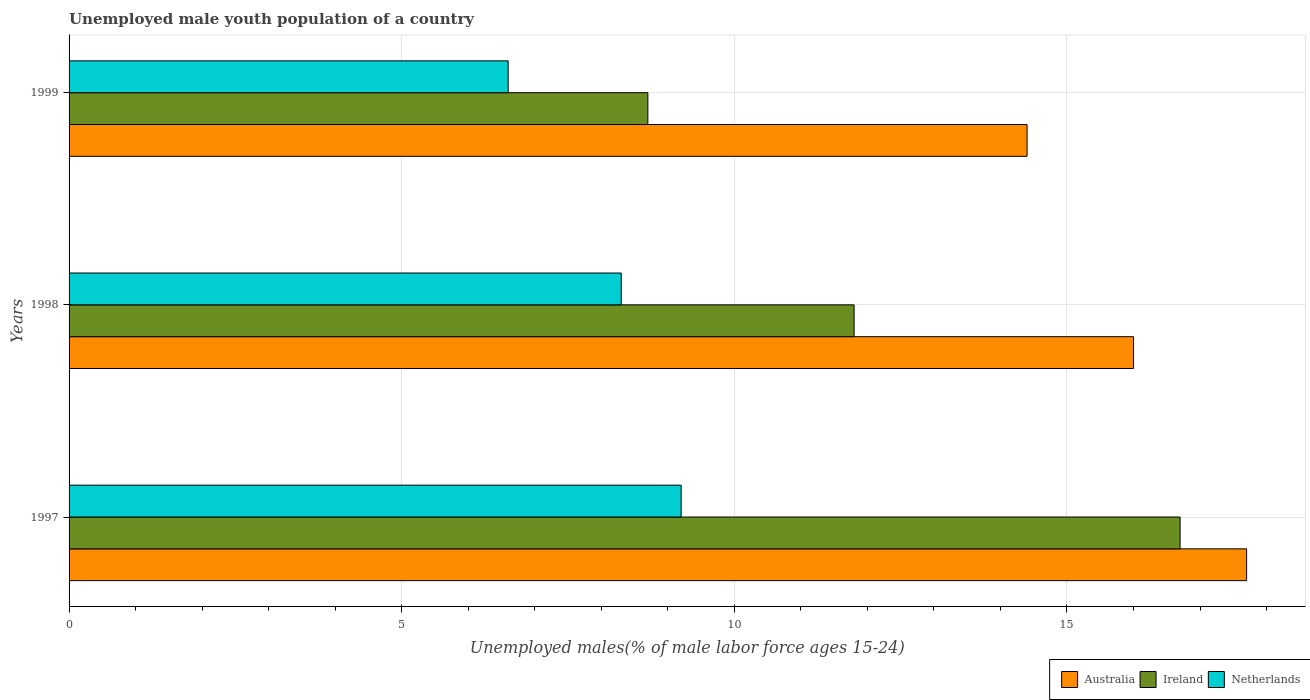How many different coloured bars are there?
Your response must be concise. 3. How many groups of bars are there?
Offer a terse response. 3. Are the number of bars per tick equal to the number of legend labels?
Ensure brevity in your answer.  Yes. How many bars are there on the 3rd tick from the top?
Ensure brevity in your answer.  3. How many bars are there on the 3rd tick from the bottom?
Provide a succinct answer. 3. Across all years, what is the maximum percentage of unemployed male youth population in Ireland?
Your response must be concise. 16.7. Across all years, what is the minimum percentage of unemployed male youth population in Netherlands?
Your answer should be very brief. 6.6. In which year was the percentage of unemployed male youth population in Ireland maximum?
Your answer should be compact. 1997. What is the total percentage of unemployed male youth population in Ireland in the graph?
Your response must be concise. 37.2. What is the difference between the percentage of unemployed male youth population in Ireland in 1997 and that in 1998?
Keep it short and to the point. 4.9. What is the difference between the percentage of unemployed male youth population in Australia in 1998 and the percentage of unemployed male youth population in Netherlands in 1999?
Provide a succinct answer. 9.4. What is the average percentage of unemployed male youth population in Australia per year?
Your response must be concise. 16.03. In the year 1998, what is the difference between the percentage of unemployed male youth population in Australia and percentage of unemployed male youth population in Ireland?
Your answer should be very brief. 4.2. In how many years, is the percentage of unemployed male youth population in Netherlands greater than 12 %?
Ensure brevity in your answer.  0. What is the ratio of the percentage of unemployed male youth population in Australia in 1997 to that in 1999?
Your answer should be very brief. 1.23. Is the difference between the percentage of unemployed male youth population in Australia in 1998 and 1999 greater than the difference between the percentage of unemployed male youth population in Ireland in 1998 and 1999?
Your answer should be compact. No. What is the difference between the highest and the second highest percentage of unemployed male youth population in Ireland?
Your answer should be compact. 4.9. What is the difference between the highest and the lowest percentage of unemployed male youth population in Australia?
Offer a very short reply. 3.3. Is the sum of the percentage of unemployed male youth population in Netherlands in 1997 and 1999 greater than the maximum percentage of unemployed male youth population in Australia across all years?
Your answer should be compact. No. What does the 2nd bar from the top in 1999 represents?
Make the answer very short. Ireland. What does the 2nd bar from the bottom in 1999 represents?
Provide a short and direct response. Ireland. Are the values on the major ticks of X-axis written in scientific E-notation?
Ensure brevity in your answer.  No. Does the graph contain grids?
Your response must be concise. Yes. Where does the legend appear in the graph?
Offer a terse response. Bottom right. How are the legend labels stacked?
Provide a short and direct response. Horizontal. What is the title of the graph?
Provide a short and direct response. Unemployed male youth population of a country. Does "Lebanon" appear as one of the legend labels in the graph?
Ensure brevity in your answer.  No. What is the label or title of the X-axis?
Offer a very short reply. Unemployed males(% of male labor force ages 15-24). What is the label or title of the Y-axis?
Keep it short and to the point. Years. What is the Unemployed males(% of male labor force ages 15-24) of Australia in 1997?
Offer a very short reply. 17.7. What is the Unemployed males(% of male labor force ages 15-24) in Ireland in 1997?
Your answer should be compact. 16.7. What is the Unemployed males(% of male labor force ages 15-24) of Netherlands in 1997?
Keep it short and to the point. 9.2. What is the Unemployed males(% of male labor force ages 15-24) of Australia in 1998?
Provide a succinct answer. 16. What is the Unemployed males(% of male labor force ages 15-24) of Ireland in 1998?
Offer a terse response. 11.8. What is the Unemployed males(% of male labor force ages 15-24) in Netherlands in 1998?
Provide a succinct answer. 8.3. What is the Unemployed males(% of male labor force ages 15-24) in Australia in 1999?
Make the answer very short. 14.4. What is the Unemployed males(% of male labor force ages 15-24) in Ireland in 1999?
Give a very brief answer. 8.7. What is the Unemployed males(% of male labor force ages 15-24) of Netherlands in 1999?
Provide a succinct answer. 6.6. Across all years, what is the maximum Unemployed males(% of male labor force ages 15-24) of Australia?
Give a very brief answer. 17.7. Across all years, what is the maximum Unemployed males(% of male labor force ages 15-24) in Ireland?
Provide a succinct answer. 16.7. Across all years, what is the maximum Unemployed males(% of male labor force ages 15-24) in Netherlands?
Offer a terse response. 9.2. Across all years, what is the minimum Unemployed males(% of male labor force ages 15-24) in Australia?
Keep it short and to the point. 14.4. Across all years, what is the minimum Unemployed males(% of male labor force ages 15-24) in Ireland?
Give a very brief answer. 8.7. Across all years, what is the minimum Unemployed males(% of male labor force ages 15-24) of Netherlands?
Keep it short and to the point. 6.6. What is the total Unemployed males(% of male labor force ages 15-24) in Australia in the graph?
Provide a succinct answer. 48.1. What is the total Unemployed males(% of male labor force ages 15-24) of Ireland in the graph?
Offer a very short reply. 37.2. What is the total Unemployed males(% of male labor force ages 15-24) in Netherlands in the graph?
Provide a succinct answer. 24.1. What is the difference between the Unemployed males(% of male labor force ages 15-24) of Ireland in 1997 and that in 1998?
Provide a succinct answer. 4.9. What is the difference between the Unemployed males(% of male labor force ages 15-24) in Netherlands in 1997 and that in 1998?
Offer a terse response. 0.9. What is the difference between the Unemployed males(% of male labor force ages 15-24) in Australia in 1998 and that in 1999?
Your answer should be very brief. 1.6. What is the difference between the Unemployed males(% of male labor force ages 15-24) in Ireland in 1998 and that in 1999?
Provide a succinct answer. 3.1. What is the difference between the Unemployed males(% of male labor force ages 15-24) in Netherlands in 1998 and that in 1999?
Provide a short and direct response. 1.7. What is the difference between the Unemployed males(% of male labor force ages 15-24) of Australia in 1997 and the Unemployed males(% of male labor force ages 15-24) of Ireland in 1999?
Ensure brevity in your answer.  9. What is the difference between the Unemployed males(% of male labor force ages 15-24) of Australia in 1997 and the Unemployed males(% of male labor force ages 15-24) of Netherlands in 1999?
Make the answer very short. 11.1. What is the difference between the Unemployed males(% of male labor force ages 15-24) of Ireland in 1997 and the Unemployed males(% of male labor force ages 15-24) of Netherlands in 1999?
Make the answer very short. 10.1. What is the difference between the Unemployed males(% of male labor force ages 15-24) in Ireland in 1998 and the Unemployed males(% of male labor force ages 15-24) in Netherlands in 1999?
Provide a succinct answer. 5.2. What is the average Unemployed males(% of male labor force ages 15-24) of Australia per year?
Your answer should be compact. 16.03. What is the average Unemployed males(% of male labor force ages 15-24) in Netherlands per year?
Your answer should be compact. 8.03. In the year 1997, what is the difference between the Unemployed males(% of male labor force ages 15-24) in Australia and Unemployed males(% of male labor force ages 15-24) in Ireland?
Your answer should be compact. 1. In the year 1997, what is the difference between the Unemployed males(% of male labor force ages 15-24) of Ireland and Unemployed males(% of male labor force ages 15-24) of Netherlands?
Your answer should be very brief. 7.5. In the year 1998, what is the difference between the Unemployed males(% of male labor force ages 15-24) in Australia and Unemployed males(% of male labor force ages 15-24) in Netherlands?
Your answer should be very brief. 7.7. In the year 1999, what is the difference between the Unemployed males(% of male labor force ages 15-24) of Australia and Unemployed males(% of male labor force ages 15-24) of Ireland?
Make the answer very short. 5.7. In the year 1999, what is the difference between the Unemployed males(% of male labor force ages 15-24) of Ireland and Unemployed males(% of male labor force ages 15-24) of Netherlands?
Give a very brief answer. 2.1. What is the ratio of the Unemployed males(% of male labor force ages 15-24) in Australia in 1997 to that in 1998?
Offer a very short reply. 1.11. What is the ratio of the Unemployed males(% of male labor force ages 15-24) of Ireland in 1997 to that in 1998?
Keep it short and to the point. 1.42. What is the ratio of the Unemployed males(% of male labor force ages 15-24) in Netherlands in 1997 to that in 1998?
Keep it short and to the point. 1.11. What is the ratio of the Unemployed males(% of male labor force ages 15-24) of Australia in 1997 to that in 1999?
Provide a short and direct response. 1.23. What is the ratio of the Unemployed males(% of male labor force ages 15-24) in Ireland in 1997 to that in 1999?
Make the answer very short. 1.92. What is the ratio of the Unemployed males(% of male labor force ages 15-24) in Netherlands in 1997 to that in 1999?
Ensure brevity in your answer.  1.39. What is the ratio of the Unemployed males(% of male labor force ages 15-24) in Australia in 1998 to that in 1999?
Your response must be concise. 1.11. What is the ratio of the Unemployed males(% of male labor force ages 15-24) of Ireland in 1998 to that in 1999?
Your response must be concise. 1.36. What is the ratio of the Unemployed males(% of male labor force ages 15-24) of Netherlands in 1998 to that in 1999?
Your response must be concise. 1.26. What is the difference between the highest and the second highest Unemployed males(% of male labor force ages 15-24) in Australia?
Your answer should be compact. 1.7. What is the difference between the highest and the lowest Unemployed males(% of male labor force ages 15-24) in Australia?
Make the answer very short. 3.3. What is the difference between the highest and the lowest Unemployed males(% of male labor force ages 15-24) in Ireland?
Provide a succinct answer. 8. 